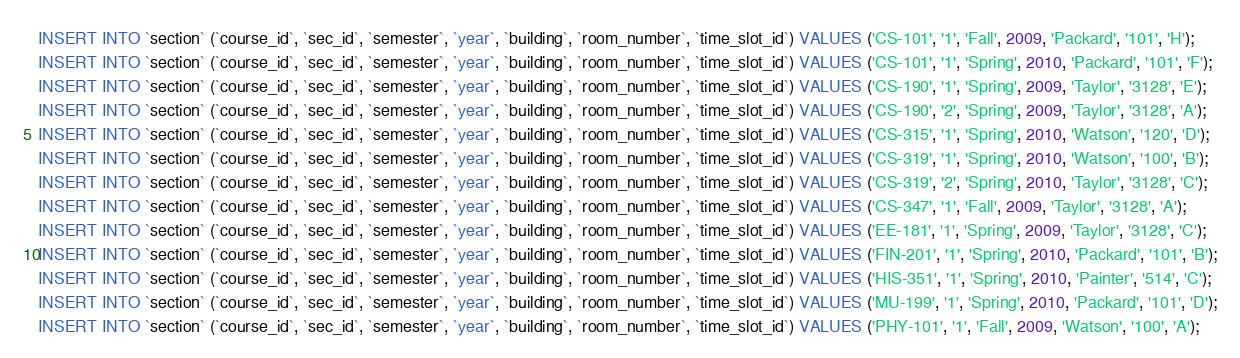<code> <loc_0><loc_0><loc_500><loc_500><_SQL_>INSERT INTO `section` (`course_id`, `sec_id`, `semester`, `year`, `building`, `room_number`, `time_slot_id`) VALUES ('CS-101', '1', 'Fall', 2009, 'Packard', '101', 'H');
INSERT INTO `section` (`course_id`, `sec_id`, `semester`, `year`, `building`, `room_number`, `time_slot_id`) VALUES ('CS-101', '1', 'Spring', 2010, 'Packard', '101', 'F');
INSERT INTO `section` (`course_id`, `sec_id`, `semester`, `year`, `building`, `room_number`, `time_slot_id`) VALUES ('CS-190', '1', 'Spring', 2009, 'Taylor', '3128', 'E');
INSERT INTO `section` (`course_id`, `sec_id`, `semester`, `year`, `building`, `room_number`, `time_slot_id`) VALUES ('CS-190', '2', 'Spring', 2009, 'Taylor', '3128', 'A');
INSERT INTO `section` (`course_id`, `sec_id`, `semester`, `year`, `building`, `room_number`, `time_slot_id`) VALUES ('CS-315', '1', 'Spring', 2010, 'Watson', '120', 'D');
INSERT INTO `section` (`course_id`, `sec_id`, `semester`, `year`, `building`, `room_number`, `time_slot_id`) VALUES ('CS-319', '1', 'Spring', 2010, 'Watson', '100', 'B');
INSERT INTO `section` (`course_id`, `sec_id`, `semester`, `year`, `building`, `room_number`, `time_slot_id`) VALUES ('CS-319', '2', 'Spring', 2010, 'Taylor', '3128', 'C');
INSERT INTO `section` (`course_id`, `sec_id`, `semester`, `year`, `building`, `room_number`, `time_slot_id`) VALUES ('CS-347', '1', 'Fall', 2009, 'Taylor', '3128', 'A');
INSERT INTO `section` (`course_id`, `sec_id`, `semester`, `year`, `building`, `room_number`, `time_slot_id`) VALUES ('EE-181', '1', 'Spring', 2009, 'Taylor', '3128', 'C');
INSERT INTO `section` (`course_id`, `sec_id`, `semester`, `year`, `building`, `room_number`, `time_slot_id`) VALUES ('FIN-201', '1', 'Spring', 2010, 'Packard', '101', 'B');
INSERT INTO `section` (`course_id`, `sec_id`, `semester`, `year`, `building`, `room_number`, `time_slot_id`) VALUES ('HIS-351', '1', 'Spring', 2010, 'Painter', '514', 'C');
INSERT INTO `section` (`course_id`, `sec_id`, `semester`, `year`, `building`, `room_number`, `time_slot_id`) VALUES ('MU-199', '1', 'Spring', 2010, 'Packard', '101', 'D');
INSERT INTO `section` (`course_id`, `sec_id`, `semester`, `year`, `building`, `room_number`, `time_slot_id`) VALUES ('PHY-101', '1', 'Fall', 2009, 'Watson', '100', 'A');
</code> 